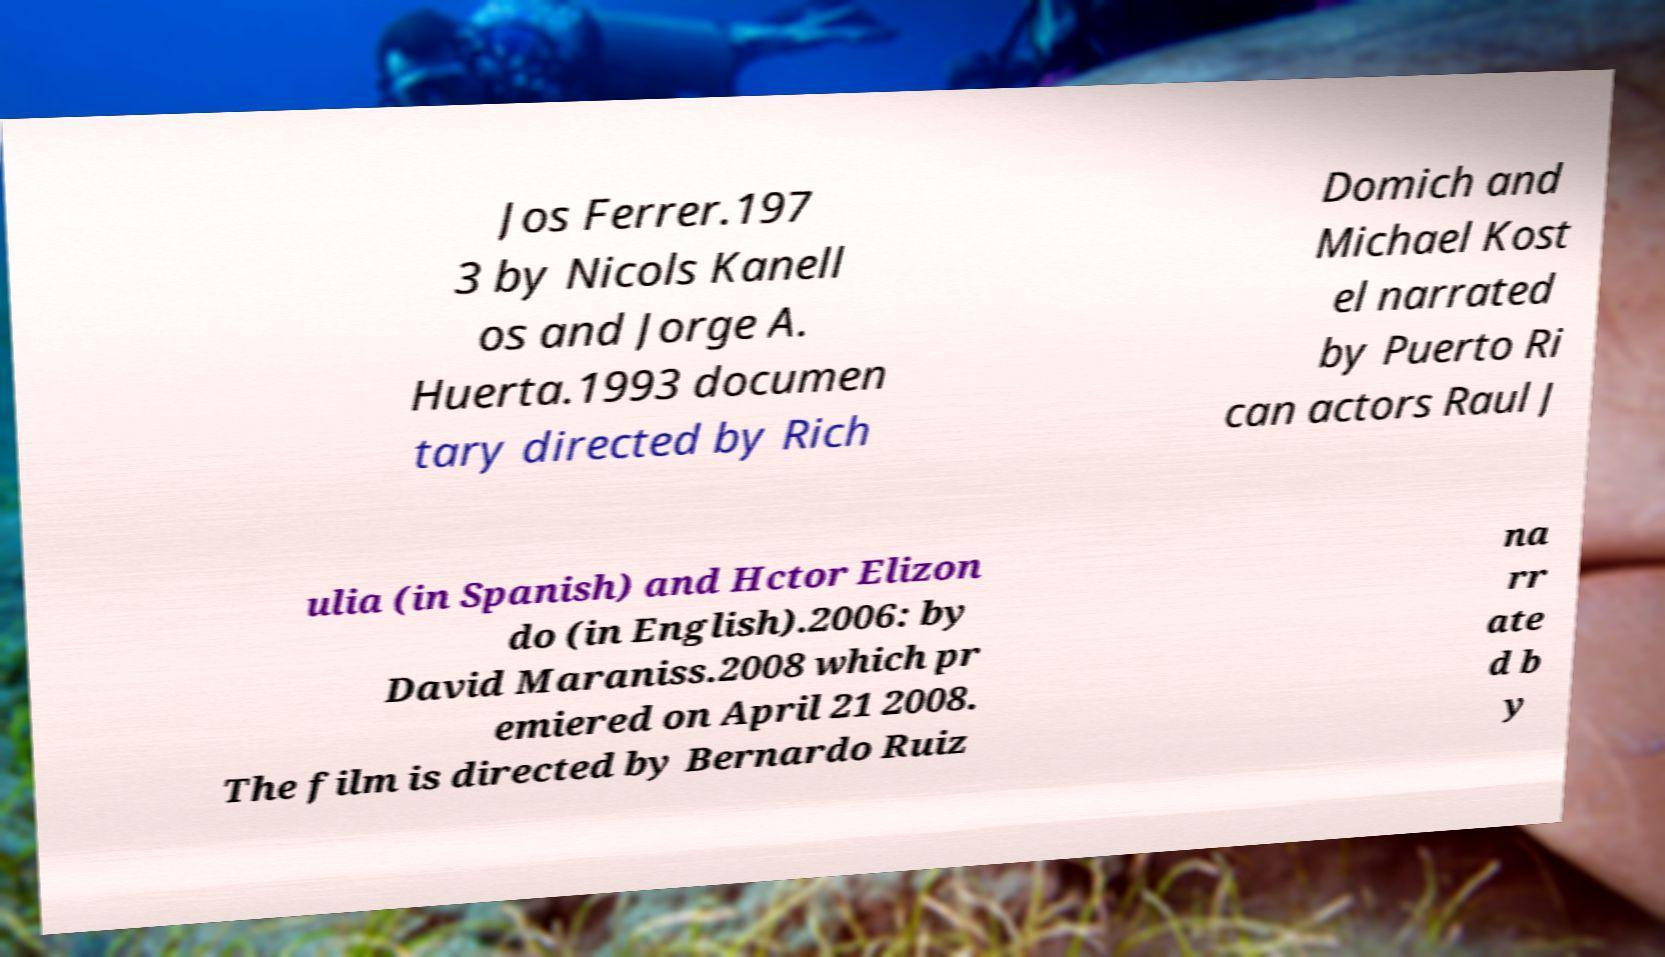Can you accurately transcribe the text from the provided image for me? Jos Ferrer.197 3 by Nicols Kanell os and Jorge A. Huerta.1993 documen tary directed by Rich Domich and Michael Kost el narrated by Puerto Ri can actors Raul J ulia (in Spanish) and Hctor Elizon do (in English).2006: by David Maraniss.2008 which pr emiered on April 21 2008. The film is directed by Bernardo Ruiz na rr ate d b y 